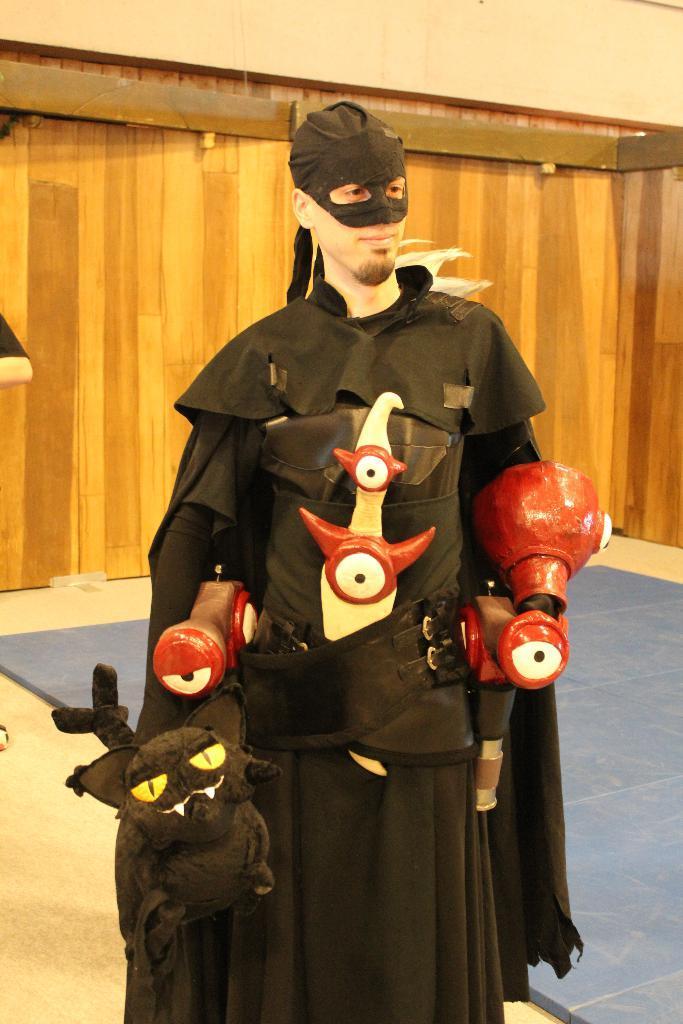In one or two sentences, can you explain what this image depicts? In the image we can see a person wearing the costume and holding a toy in hand. Here we can see the floor and the wooden wall. 